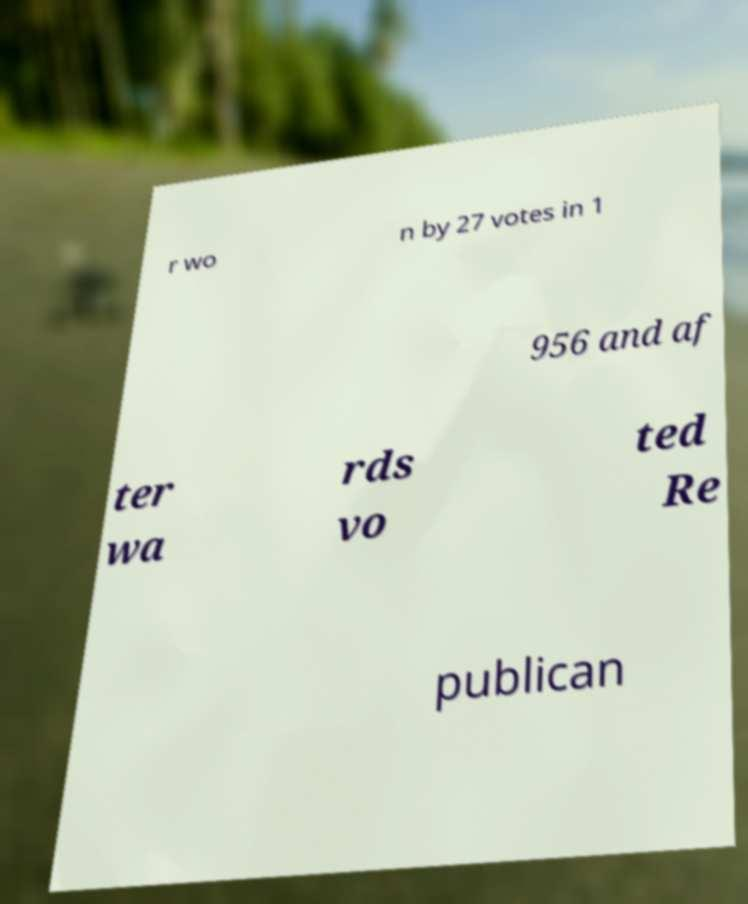Can you accurately transcribe the text from the provided image for me? r wo n by 27 votes in 1 956 and af ter wa rds vo ted Re publican 